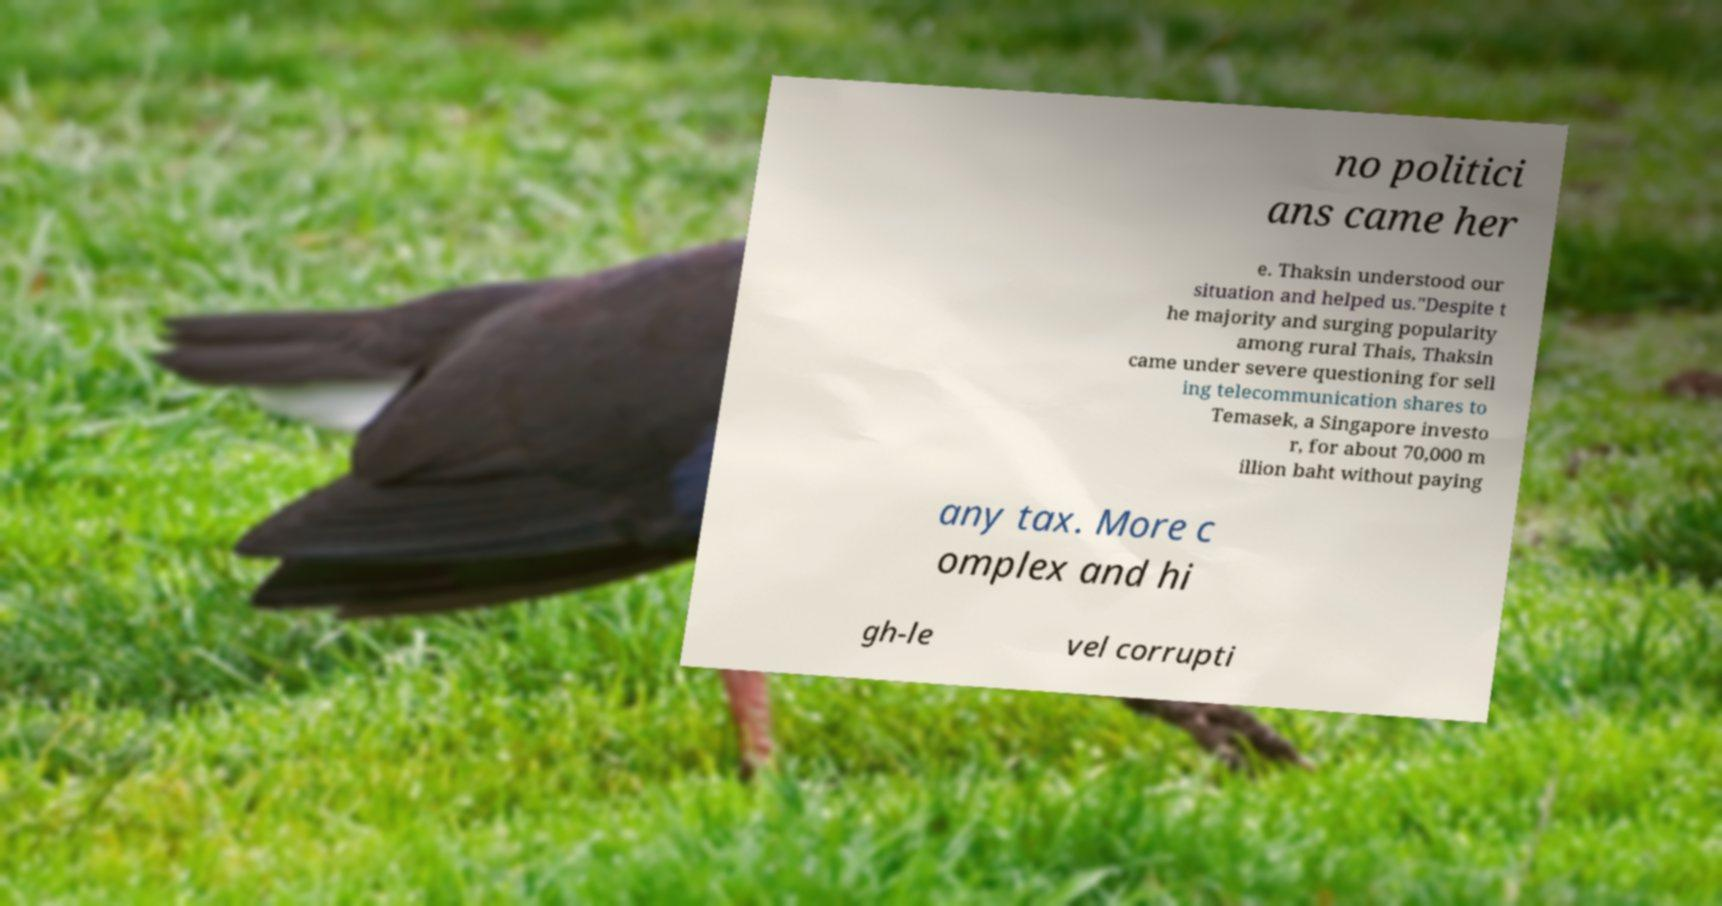I need the written content from this picture converted into text. Can you do that? no politici ans came her e. Thaksin understood our situation and helped us."Despite t he majority and surging popularity among rural Thais, Thaksin came under severe questioning for sell ing telecommunication shares to Temasek, a Singapore investo r, for about 70,000 m illion baht without paying any tax. More c omplex and hi gh-le vel corrupti 